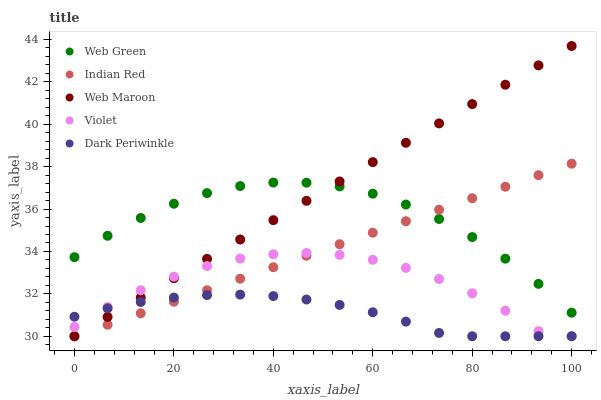Does Dark Periwinkle have the minimum area under the curve?
Answer yes or no. Yes. Does Web Maroon have the maximum area under the curve?
Answer yes or no. Yes. Does Indian Red have the minimum area under the curve?
Answer yes or no. No. Does Indian Red have the maximum area under the curve?
Answer yes or no. No. Is Indian Red the smoothest?
Answer yes or no. Yes. Is Violet the roughest?
Answer yes or no. Yes. Is Web Maroon the smoothest?
Answer yes or no. No. Is Web Maroon the roughest?
Answer yes or no. No. Does Dark Periwinkle have the lowest value?
Answer yes or no. Yes. Does Web Green have the lowest value?
Answer yes or no. No. Does Web Maroon have the highest value?
Answer yes or no. Yes. Does Indian Red have the highest value?
Answer yes or no. No. Is Dark Periwinkle less than Web Green?
Answer yes or no. Yes. Is Web Green greater than Violet?
Answer yes or no. Yes. Does Web Maroon intersect Violet?
Answer yes or no. Yes. Is Web Maroon less than Violet?
Answer yes or no. No. Is Web Maroon greater than Violet?
Answer yes or no. No. Does Dark Periwinkle intersect Web Green?
Answer yes or no. No. 